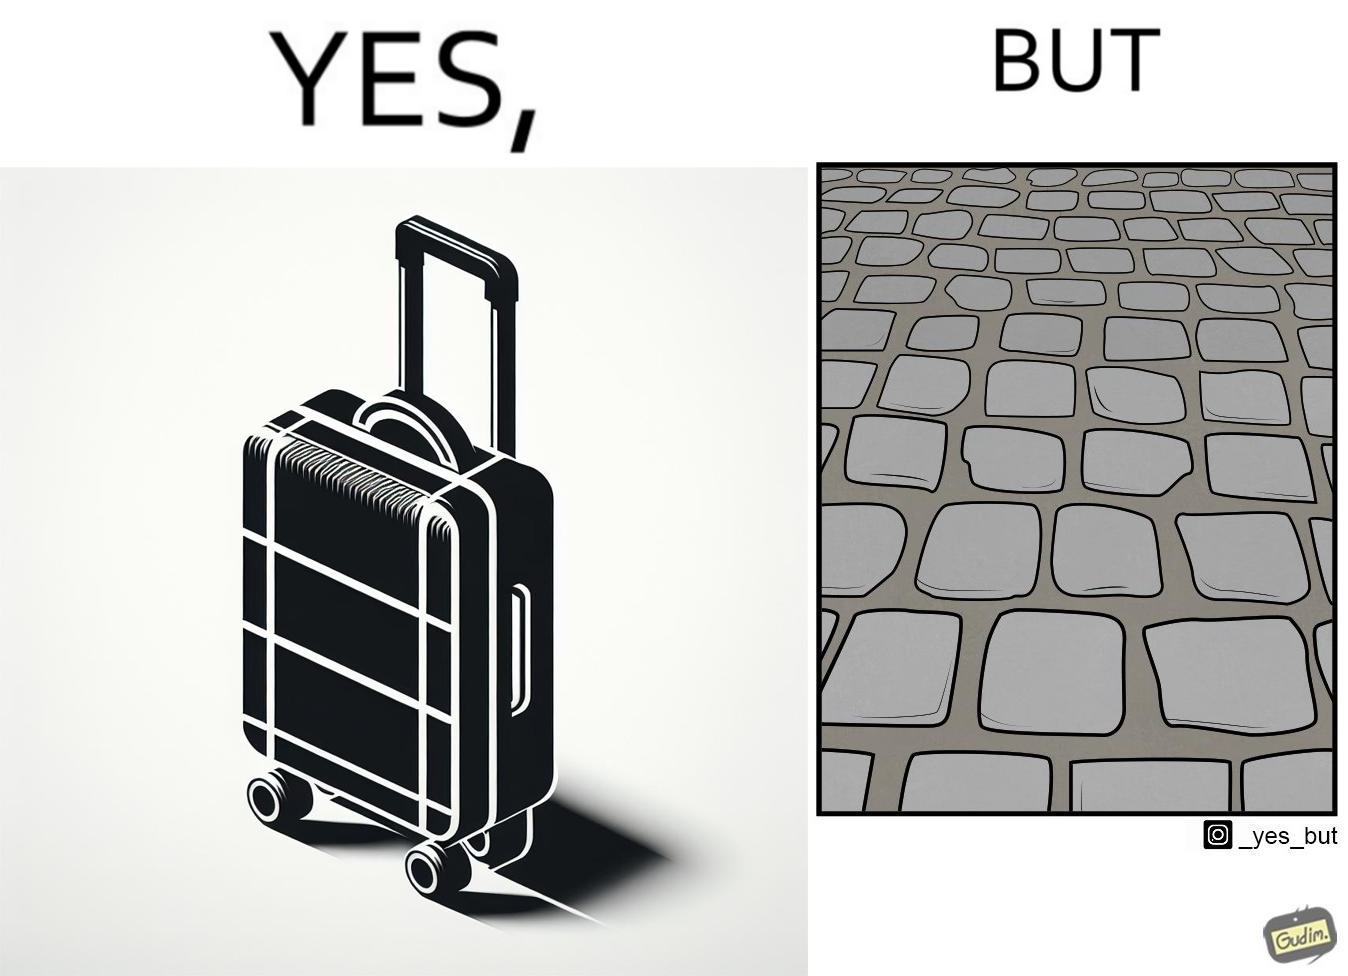What is shown in the left half versus the right half of this image? In the left part of the image: it is a trolley luggage bag In the right part of the image: It is a cobblestone road 